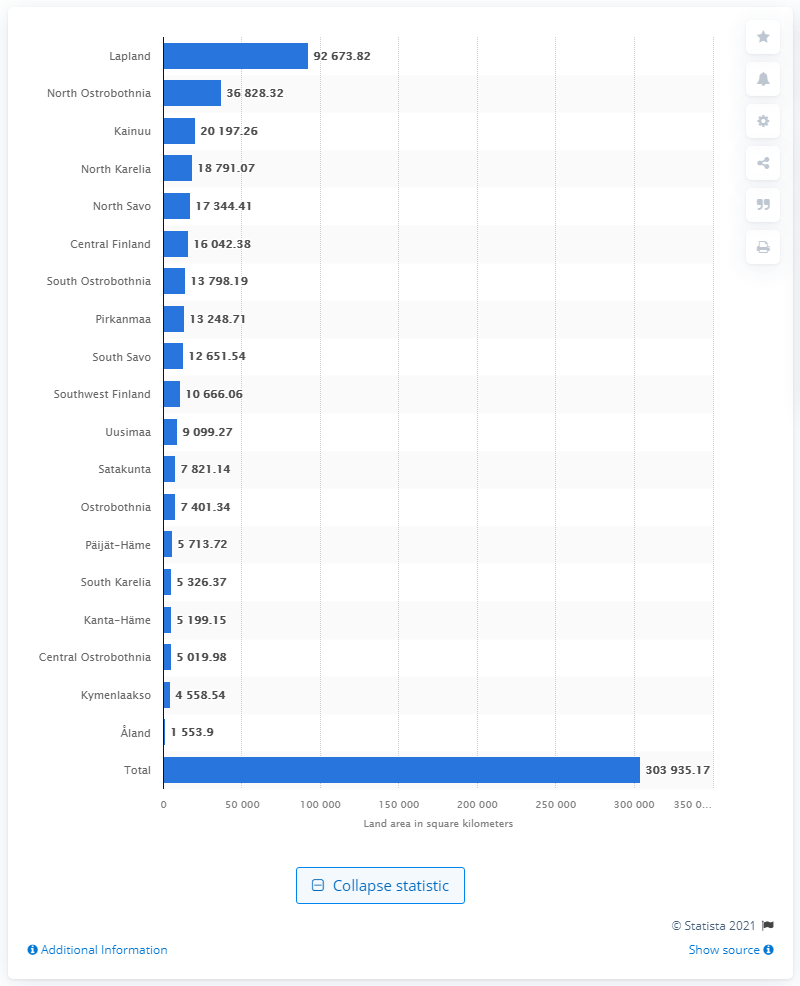Point out several critical features in this image. Lapland is the largest region in Finland by land area. 